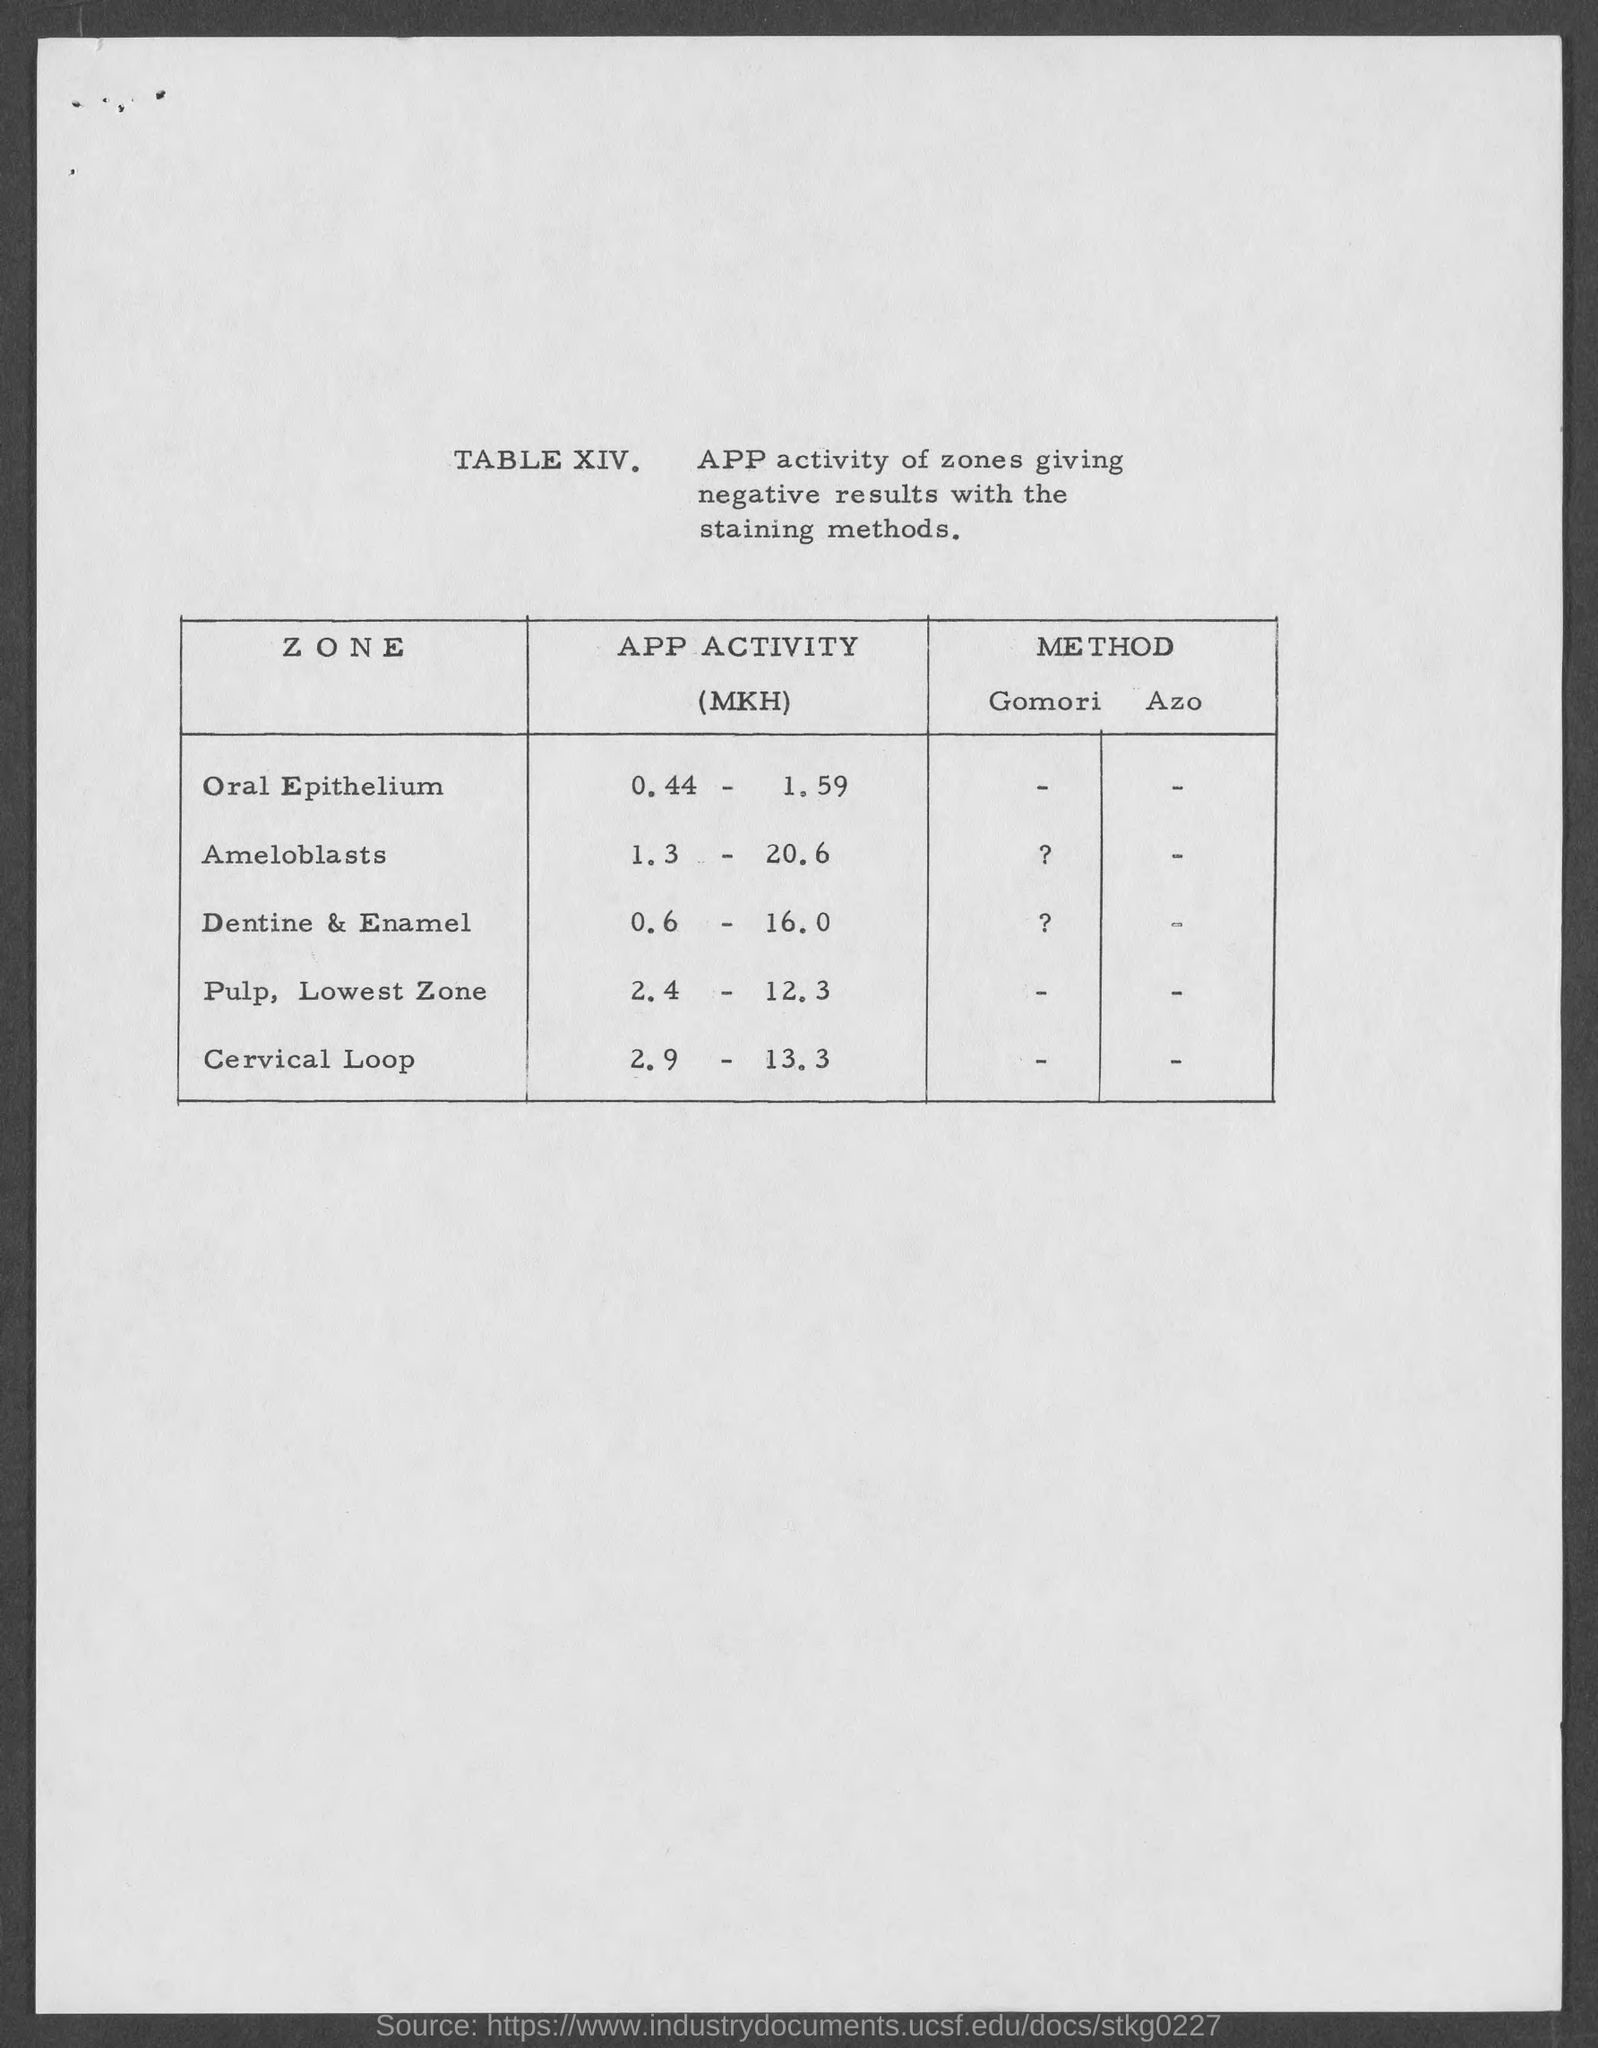What is the app activity for oral epithelium zone ?
Make the answer very short. 0.44 -1.59 MKH. What is the app activity for ameloblasts zone ?
Offer a very short reply. 1.3-20.6 MKH. What is the app activity for dentine & enamel zone ?
Provide a succinct answer. 0.6 - 16.0 MKH. What is the app activity for pulp, lowest zone ?
Ensure brevity in your answer.  2.4 - 12.3 MKH. What is the app activity for cervical loop zone?
Provide a short and direct response. 2.9 - 13.3 MKH. 